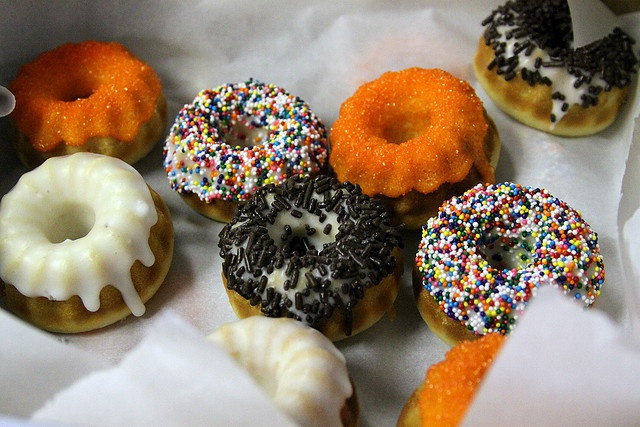Describe the objects in this image and their specific colors. I can see donut in gray, beige, darkgray, and maroon tones, donut in gray, black, and darkgray tones, donut in gray, black, lightgray, darkgray, and maroon tones, donut in gray, red, brown, black, and maroon tones, and donut in gray, lightgray, black, maroon, and darkgray tones in this image. 